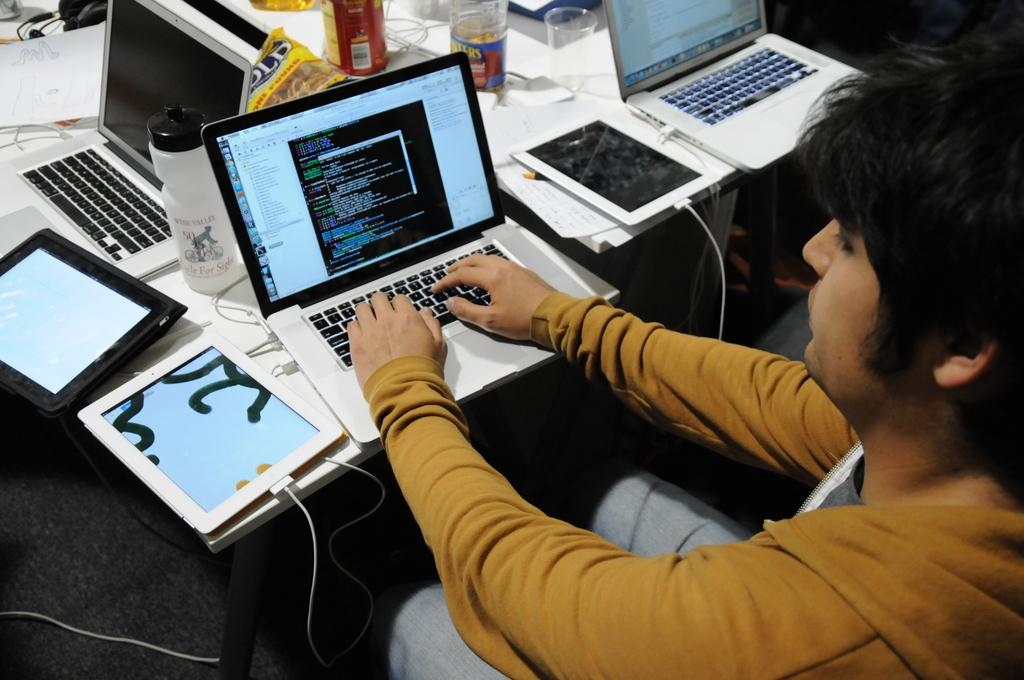What is the person in the image doing? The person in the image is operating a laptop. How many laptops are visible in the image? There is one laptop being operated by the person, and there are other laptops visible in the image. What other electronic devices can be seen in the image? There are iPads visible in the image. What objects are on the table in the image? There are bottles on the table in the image. What type of reward is being given to the person for operating the laptop in the image? There is no indication of a reward being given in the image; the person is simply operating a laptop. 